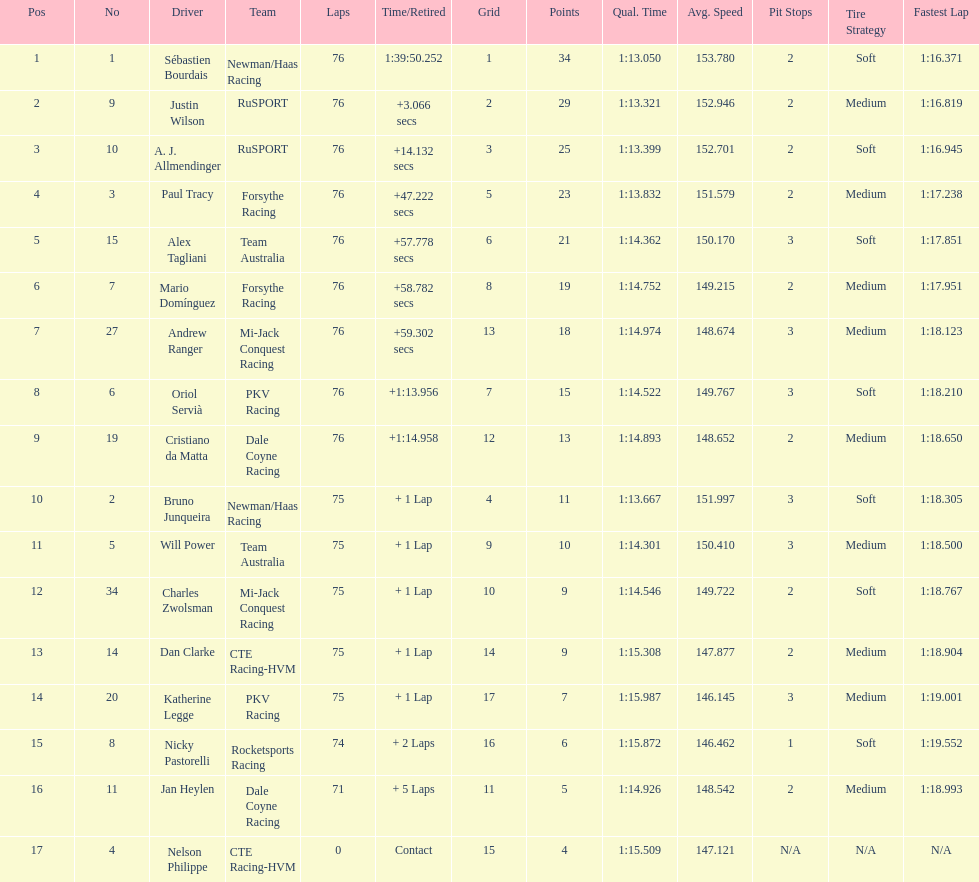Help me parse the entirety of this table. {'header': ['Pos', 'No', 'Driver', 'Team', 'Laps', 'Time/Retired', 'Grid', 'Points', 'Qual. Time', 'Avg. Speed', 'Pit Stops', 'Tire Strategy', 'Fastest Lap'], 'rows': [['1', '1', 'Sébastien Bourdais', 'Newman/Haas Racing', '76', '1:39:50.252', '1', '34', '1:13.050', '153.780', '2', 'Soft', '1:16.371'], ['2', '9', 'Justin Wilson', 'RuSPORT', '76', '+3.066 secs', '2', '29', '1:13.321', '152.946', '2', 'Medium', '1:16.819'], ['3', '10', 'A. J. Allmendinger', 'RuSPORT', '76', '+14.132 secs', '3', '25', '1:13.399', '152.701', '2', 'Soft', '1:16.945'], ['4', '3', 'Paul Tracy', 'Forsythe Racing', '76', '+47.222 secs', '5', '23', '1:13.832', '151.579', '2', 'Medium', '1:17.238'], ['5', '15', 'Alex Tagliani', 'Team Australia', '76', '+57.778 secs', '6', '21', '1:14.362', '150.170', '3', 'Soft', '1:17.851'], ['6', '7', 'Mario Domínguez', 'Forsythe Racing', '76', '+58.782 secs', '8', '19', '1:14.752', '149.215', '2', 'Medium', '1:17.951'], ['7', '27', 'Andrew Ranger', 'Mi-Jack Conquest Racing', '76', '+59.302 secs', '13', '18', '1:14.974', '148.674', '3', 'Medium', '1:18.123'], ['8', '6', 'Oriol Servià', 'PKV Racing', '76', '+1:13.956', '7', '15', '1:14.522', '149.767', '3', 'Soft', '1:18.210'], ['9', '19', 'Cristiano da Matta', 'Dale Coyne Racing', '76', '+1:14.958', '12', '13', '1:14.893', '148.652', '2', 'Medium', '1:18.650'], ['10', '2', 'Bruno Junqueira', 'Newman/Haas Racing', '75', '+ 1 Lap', '4', '11', '1:13.667', '151.997', '3', 'Soft', '1:18.305'], ['11', '5', 'Will Power', 'Team Australia', '75', '+ 1 Lap', '9', '10', '1:14.301', '150.410', '3', 'Medium', '1:18.500'], ['12', '34', 'Charles Zwolsman', 'Mi-Jack Conquest Racing', '75', '+ 1 Lap', '10', '9', '1:14.546', '149.722', '2', 'Soft', '1:18.767'], ['13', '14', 'Dan Clarke', 'CTE Racing-HVM', '75', '+ 1 Lap', '14', '9', '1:15.308', '147.877', '2', 'Medium', '1:18.904'], ['14', '20', 'Katherine Legge', 'PKV Racing', '75', '+ 1 Lap', '17', '7', '1:15.987', '146.145', '3', 'Medium', '1:19.001'], ['15', '8', 'Nicky Pastorelli', 'Rocketsports Racing', '74', '+ 2 Laps', '16', '6', '1:15.872', '146.462', '1', 'Soft', '1:19.552'], ['16', '11', 'Jan Heylen', 'Dale Coyne Racing', '71', '+ 5 Laps', '11', '5', '1:14.926', '148.542', '2', 'Medium', '1:18.993'], ['17', '4', 'Nelson Philippe', 'CTE Racing-HVM', '0', 'Contact', '15', '4', '1:15.509', '147.121', 'N/A', 'N/A', 'N/A']]} Which driver earned the least amount of points. Nelson Philippe. 